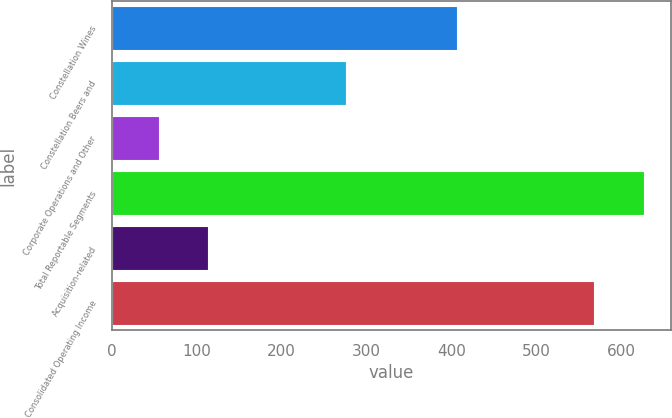Convert chart to OTSL. <chart><loc_0><loc_0><loc_500><loc_500><bar_chart><fcel>Constellation Wines<fcel>Constellation Beers and<fcel>Corporate Operations and Other<fcel>Total Reportable Segments<fcel>Acquisition-related<fcel>Consolidated Operating Income<nl><fcel>406.6<fcel>276.1<fcel>56<fcel>626.7<fcel>113.07<fcel>567.9<nl></chart> 